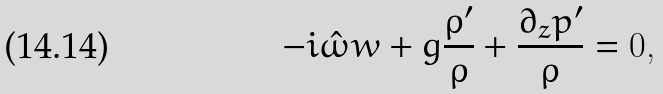Convert formula to latex. <formula><loc_0><loc_0><loc_500><loc_500>- i \hat { \omega } w + g \frac { \rho ^ { \prime } } { \rho } + \frac { \partial _ { z } p ^ { \prime } } { \rho } = 0 ,</formula> 